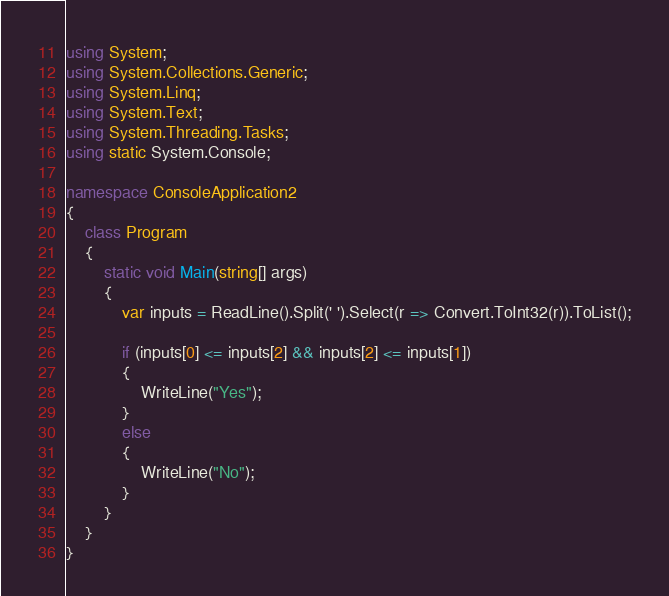<code> <loc_0><loc_0><loc_500><loc_500><_C#_>using System;
using System.Collections.Generic;
using System.Linq;
using System.Text;
using System.Threading.Tasks;
using static System.Console;

namespace ConsoleApplication2
{
	class Program
	{
		static void Main(string[] args)
		{
			var inputs = ReadLine().Split(' ').Select(r => Convert.ToInt32(r)).ToList();

			if (inputs[0] <= inputs[2] && inputs[2] <= inputs[1])
			{
				WriteLine("Yes");
			}
			else
			{
				WriteLine("No");
			}
		}
	}
}
</code> 